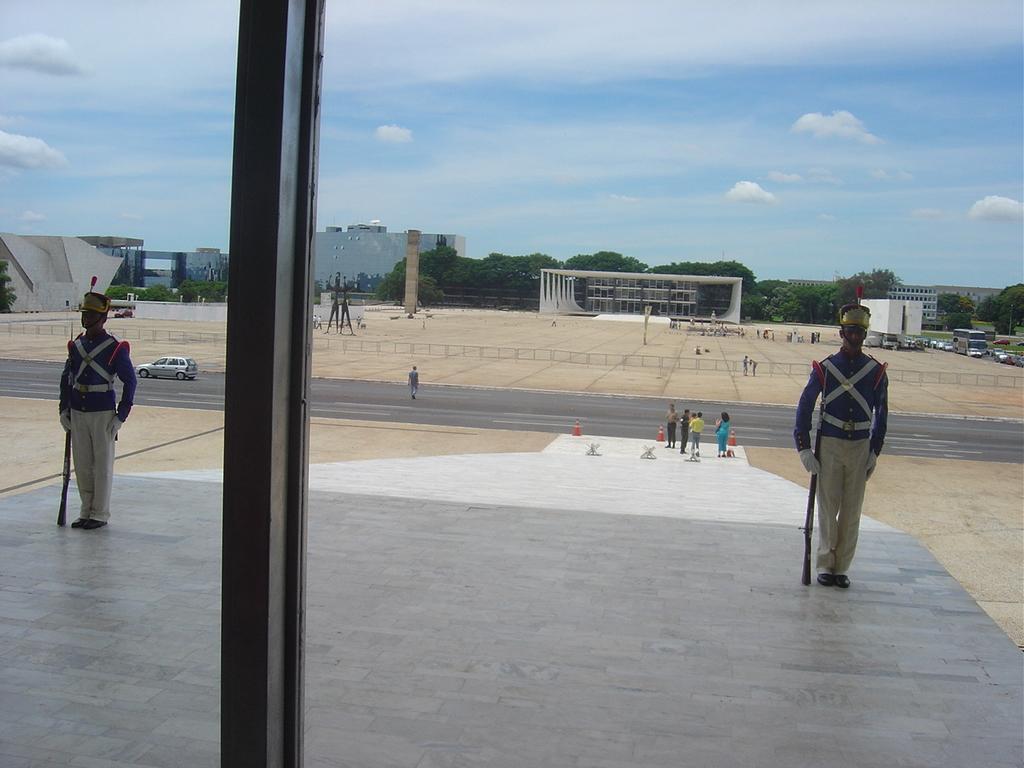In one or two sentences, can you explain what this image depicts? On the left side there is a pole. On the right and left sides of the image I can see two persons are standing by holding the guns in the hands. In the background there are few people on the ground and also I can see few vehicles. In the background there are some buildings and trees. At the top of the image I can see the sky and clouds. 